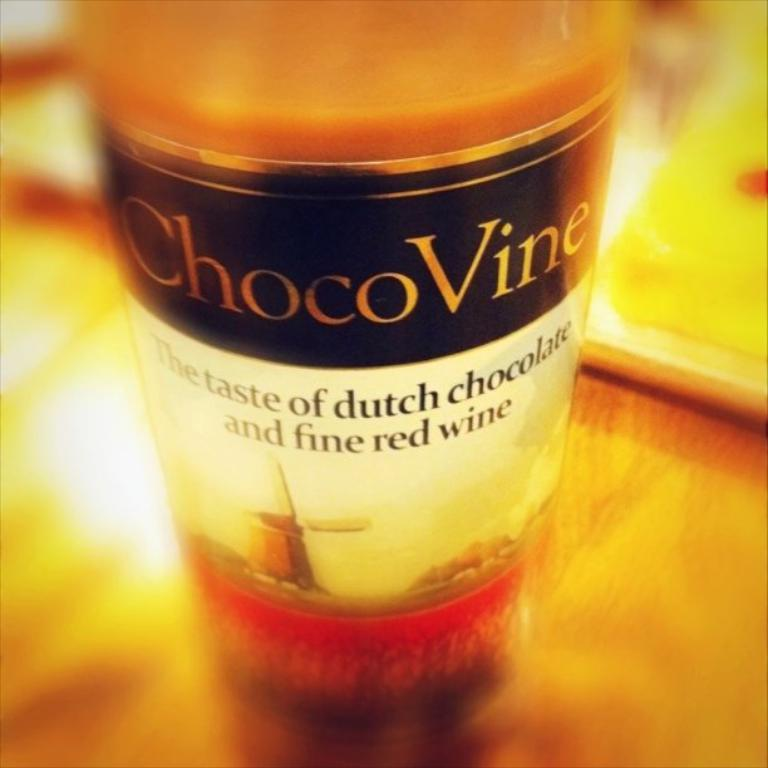<image>
Share a concise interpretation of the image provided. A bottle of ChocoVine, which is a blend of wine and chocolate. 